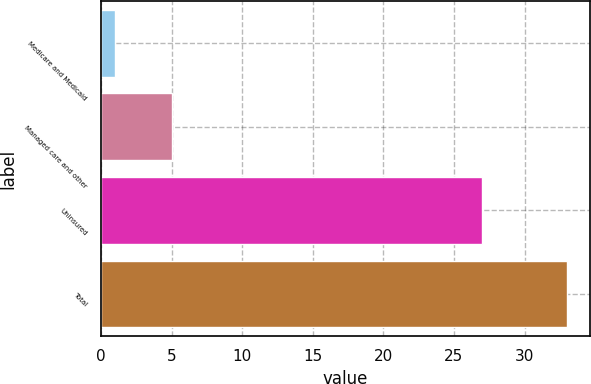<chart> <loc_0><loc_0><loc_500><loc_500><bar_chart><fcel>Medicare and Medicaid<fcel>Managed care and other<fcel>Uninsured<fcel>Total<nl><fcel>1<fcel>5<fcel>27<fcel>33<nl></chart> 